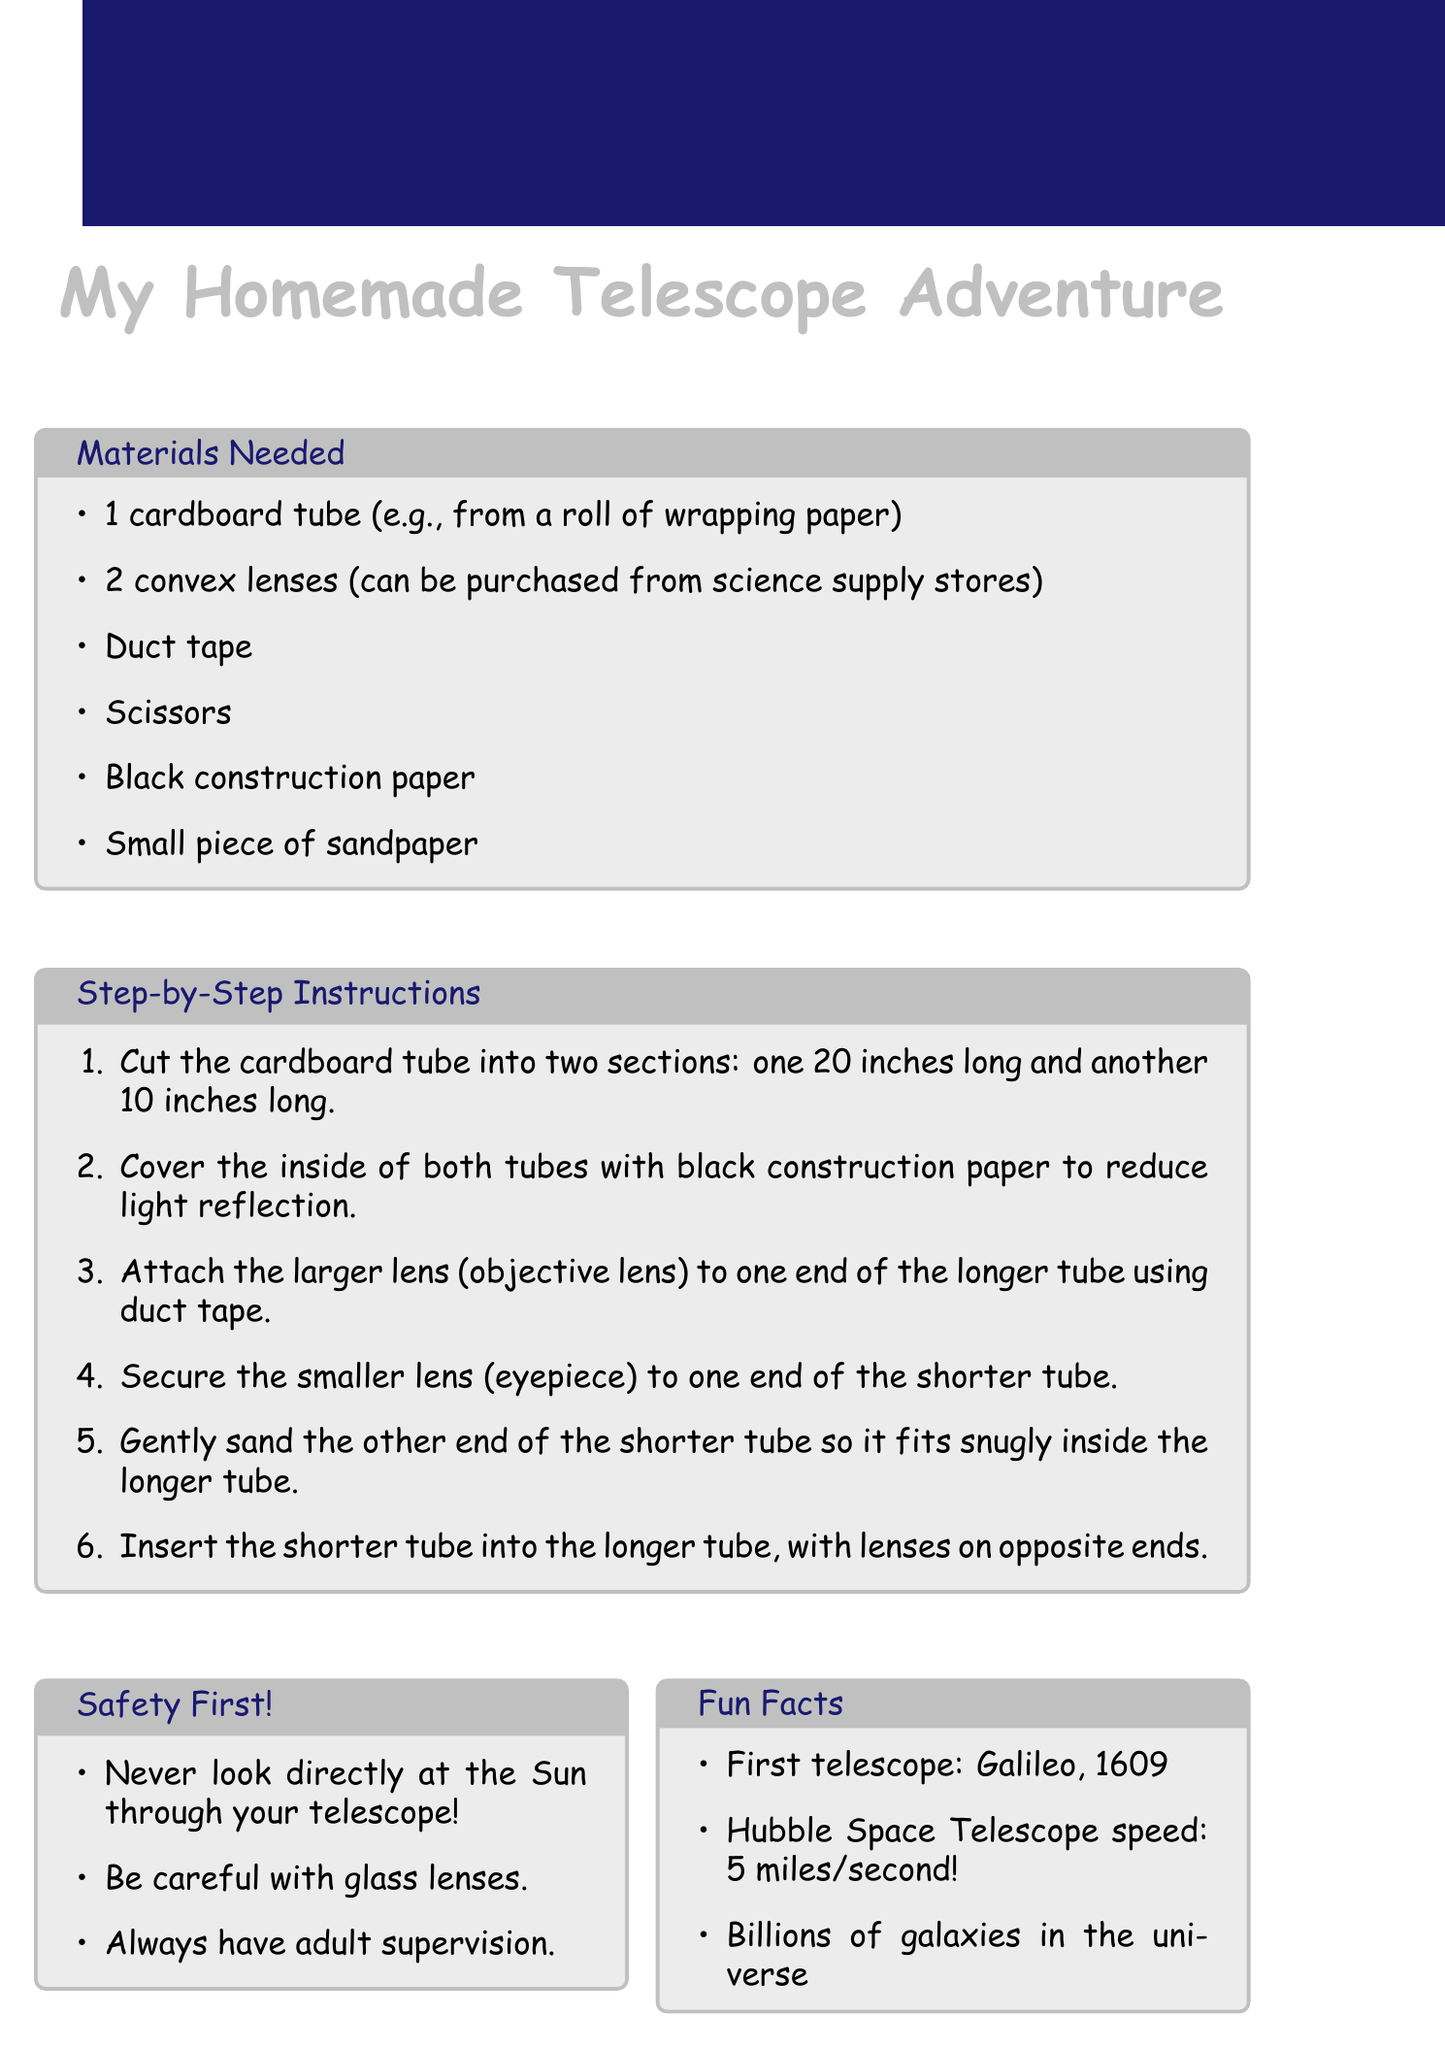What materials are needed to build the telescope? The document lists materials necessary for the telescope construction, such as cardboard tube and lenses.
Answer: Cardboard tube, convex lenses, duct tape, scissors, black construction paper, sandpaper What is the length of the longer tube? Step 1 of the instructions specifies the dimensions for cutting the cardboard tubes.
Answer: 20 inches What should be covered with black construction paper? Step 2 mentions where to use black construction paper to enhance telescope performance.
Answer: Inside of both tubes Why should an adult supervise when using tools? The safety section emphasizes the importance of supervision for handling tools.
Answer: Safety precautions Who invented the first telescope? The fun facts section mentions historical figures related to telescopes.
Answer: Galileo Galilei What book is recommended for young astronomers? The recommended books section highlights various books for stargazing enthusiasts.
Answer: The Stars: A New Way to See Them How fast does the Hubble Space Telescope orbit Earth? The fun facts offer interesting statistics about the Hubble Space Telescope.
Answer: 5 miles per second What should you never do with the telescope? The safety precautions list critical warnings for telescope usage.
Answer: Look directly at the Sun 